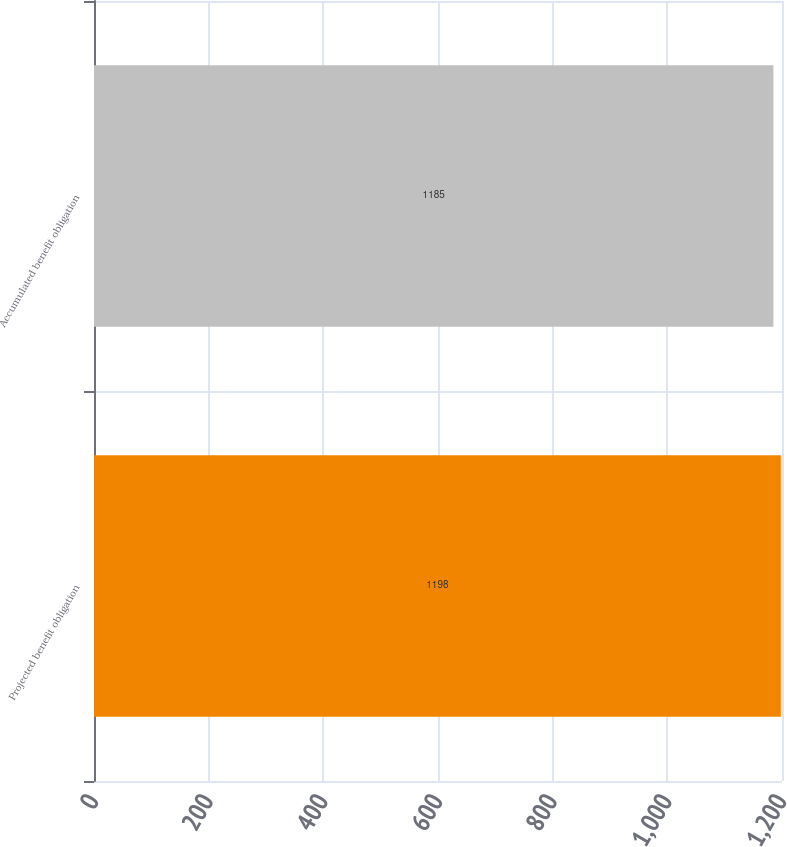<chart> <loc_0><loc_0><loc_500><loc_500><bar_chart><fcel>Projected benefit obligation<fcel>Accumulated benefit obligation<nl><fcel>1198<fcel>1185<nl></chart> 